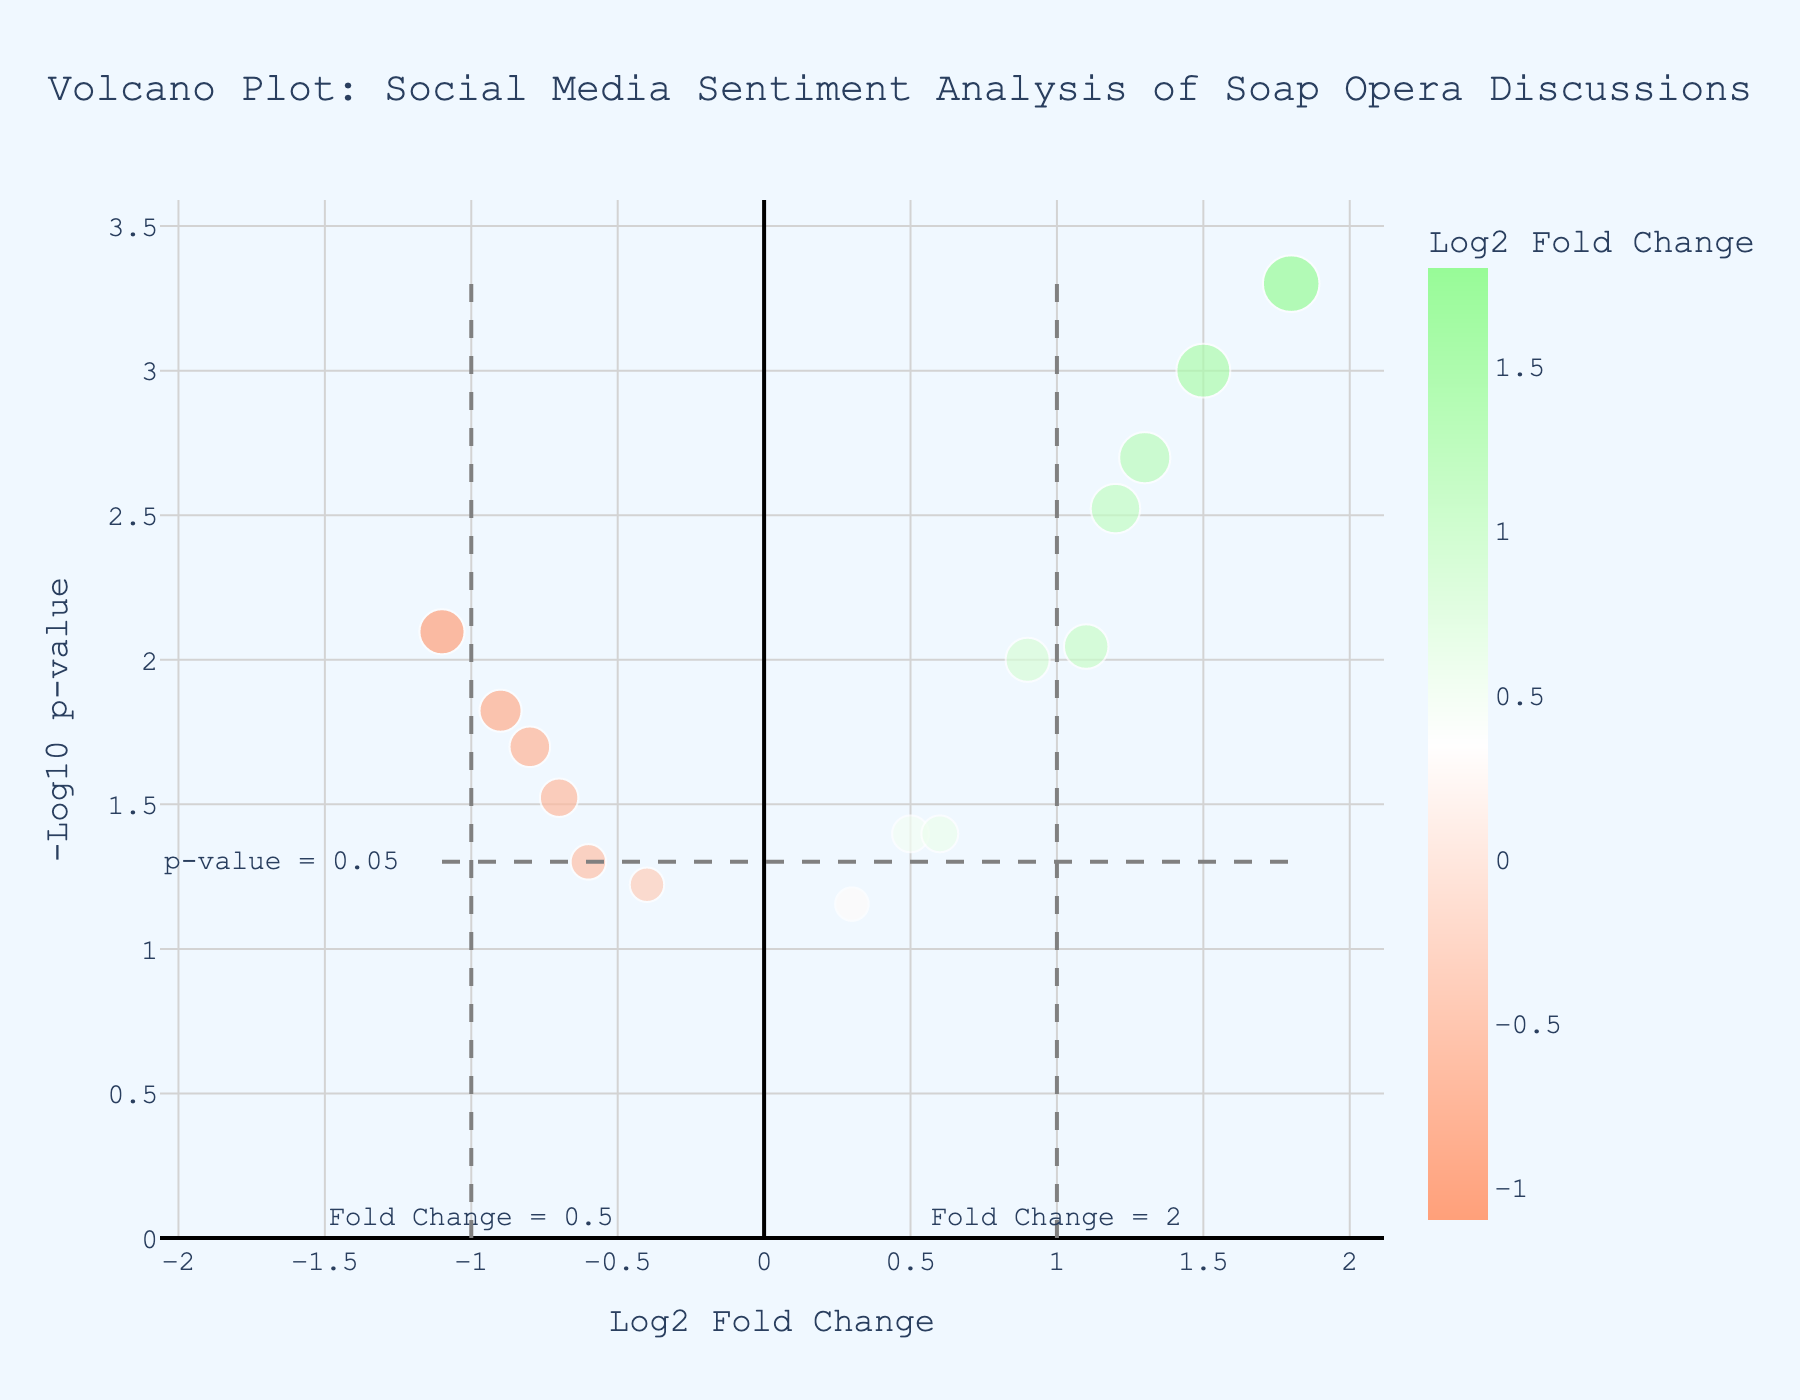How many soap operas have a positive log2 fold change? To determine how many soap operas have a positive log2 fold change, look for points on the plot where the log2 fold change (x-axis) is greater than 0.
Answer: 8 Which soap opera has the highest -log10 p-value on Twitter? To find the soap opera with the highest -log10 p-value on Twitter, identify the points corresponding to Twitter and then find the one with the maximum y-value.
Answer: Emmerdale What is the log2 fold change of "Neighbours" on Instagram? Locate the point associated with "Neighbours" on Instagram and observe its x-coordinate (log2 fold change).
Answer: -1.1 Compare the sentiment of "Days of Our Lives" on Facebook with "The Bold and the Beautiful" on Twitter. Which one has a more significant negative reaction? First, find the log2 fold change for both soap operas on their respective platforms. A more negative log2 fold change indicates a more significant negative reaction. "Days of Our Lives" has a log2 fold change of -0.8, while "The Bold and the Beautiful" has 1.2.
Answer: Days of Our Lives Which data points fall outside the thresholds for significant positive and negative fold changes and p-values? Points falling outside the thresholds will have a log2 fold change greater than 1 or less than -1 and a -log10 p-value greater than -log10(0.05). Identify these points on the plot.
Answer: Emmerdale, The Young and the Restless, The Bold and the Beautiful, Neighbours, and As the World Turns What is the sentiment trend for "EastEnders" on Facebook? Locate the data point for "EastEnders" on Facebook and check its log2 fold change value. Positive values indicate a positive sentiment trend. "EastEnders" has a log2 fold change of 0.9.
Answer: Positive Are there any soap operas on Reddit with a log2 fold change greater than 1? Check the points related to Reddit and see if any have a log2 fold change (x-coordinate) greater than 1.
Answer: No Which soap opera on Instagram has the lowest p-value? Observe the points on Instagram and identify the one with the highest -log10 p-value (lowest p-value).
Answer: All My Children 